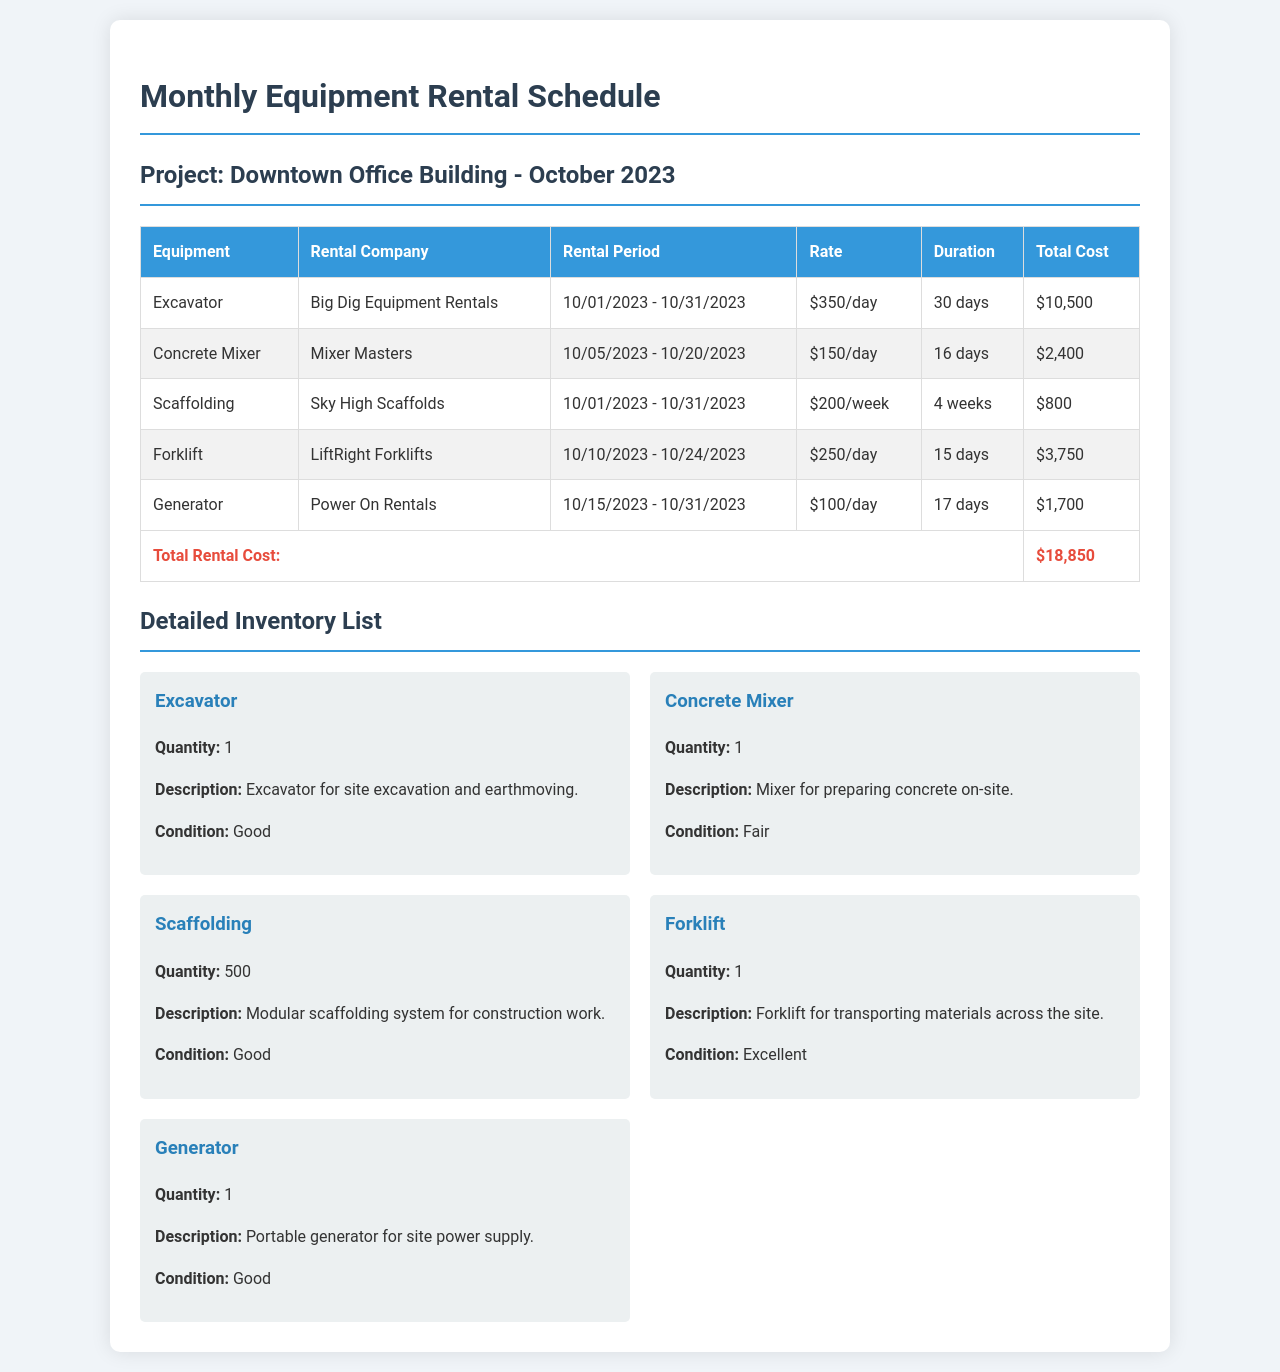What is the total rental cost? The total rental cost is calculated from the sum of total costs for each piece of equipment listed in the document.
Answer: $18,850 What is the rental period for the Excavatior? The rental period for the Excavator is specified within the table as the dates it is rented.
Answer: 10/01/2023 - 10/31/2023 How many days will the Concrete Mixer be rented? The document states the rental period duration in days for the Concrete Mixer.
Answer: 16 days Which company provides the Forklift? The table lists the rental companies for each equipment item, including the Forklift.
Answer: LiftRight Forklifts What condition is the Generator in? The condition of the Generator is mentioned in the inventory list section of the document.
Answer: Good How much is the rental rate for Scaffolding? The rental rate for Scaffolding can be found under the Rate column in the equipment rental schedule.
Answer: $200/week What equipment has a quantity of 500? The quantity for each piece of equipment is specified in the inventory list, identifying Scaffolding as having this quantity.
Answer: Scaffolding Which equipment rental company is associated with the Generator? The Generator's associated rental company can be found in the equipment rental schedule table.
Answer: Power On Rentals 